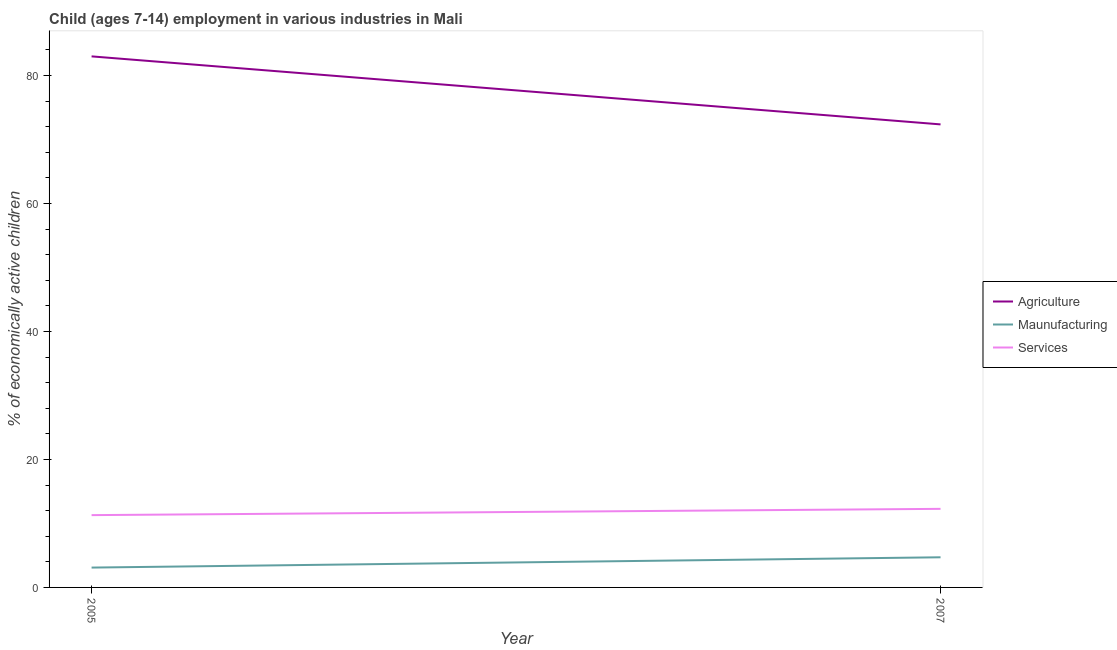What is the percentage of economically active children in manufacturing in 2007?
Your answer should be very brief. 4.71. Across all years, what is the maximum percentage of economically active children in agriculture?
Offer a terse response. 83. Across all years, what is the minimum percentage of economically active children in services?
Ensure brevity in your answer.  11.3. What is the total percentage of economically active children in manufacturing in the graph?
Your response must be concise. 7.81. What is the difference between the percentage of economically active children in manufacturing in 2005 and that in 2007?
Offer a very short reply. -1.61. What is the difference between the percentage of economically active children in services in 2007 and the percentage of economically active children in manufacturing in 2005?
Give a very brief answer. 9.18. What is the average percentage of economically active children in agriculture per year?
Provide a succinct answer. 77.69. In the year 2005, what is the difference between the percentage of economically active children in agriculture and percentage of economically active children in services?
Provide a succinct answer. 71.7. In how many years, is the percentage of economically active children in manufacturing greater than 52 %?
Provide a succinct answer. 0. What is the ratio of the percentage of economically active children in agriculture in 2005 to that in 2007?
Give a very brief answer. 1.15. In how many years, is the percentage of economically active children in services greater than the average percentage of economically active children in services taken over all years?
Provide a short and direct response. 1. Does the percentage of economically active children in services monotonically increase over the years?
Your answer should be very brief. Yes. Is the percentage of economically active children in services strictly greater than the percentage of economically active children in agriculture over the years?
Provide a short and direct response. No. Is the percentage of economically active children in services strictly less than the percentage of economically active children in manufacturing over the years?
Offer a very short reply. No. How many years are there in the graph?
Provide a short and direct response. 2. Does the graph contain any zero values?
Your answer should be very brief. No. How many legend labels are there?
Keep it short and to the point. 3. What is the title of the graph?
Your answer should be very brief. Child (ages 7-14) employment in various industries in Mali. Does "Coal sources" appear as one of the legend labels in the graph?
Your answer should be compact. No. What is the label or title of the X-axis?
Give a very brief answer. Year. What is the label or title of the Y-axis?
Provide a succinct answer. % of economically active children. What is the % of economically active children in Agriculture in 2005?
Your response must be concise. 83. What is the % of economically active children of Agriculture in 2007?
Give a very brief answer. 72.37. What is the % of economically active children in Maunufacturing in 2007?
Provide a short and direct response. 4.71. What is the % of economically active children of Services in 2007?
Make the answer very short. 12.28. Across all years, what is the maximum % of economically active children of Agriculture?
Your answer should be very brief. 83. Across all years, what is the maximum % of economically active children of Maunufacturing?
Your answer should be very brief. 4.71. Across all years, what is the maximum % of economically active children in Services?
Keep it short and to the point. 12.28. Across all years, what is the minimum % of economically active children in Agriculture?
Offer a very short reply. 72.37. Across all years, what is the minimum % of economically active children in Services?
Your answer should be compact. 11.3. What is the total % of economically active children of Agriculture in the graph?
Provide a succinct answer. 155.37. What is the total % of economically active children in Maunufacturing in the graph?
Offer a terse response. 7.81. What is the total % of economically active children in Services in the graph?
Keep it short and to the point. 23.58. What is the difference between the % of economically active children in Agriculture in 2005 and that in 2007?
Your answer should be compact. 10.63. What is the difference between the % of economically active children of Maunufacturing in 2005 and that in 2007?
Ensure brevity in your answer.  -1.61. What is the difference between the % of economically active children in Services in 2005 and that in 2007?
Your response must be concise. -0.98. What is the difference between the % of economically active children of Agriculture in 2005 and the % of economically active children of Maunufacturing in 2007?
Your answer should be very brief. 78.29. What is the difference between the % of economically active children of Agriculture in 2005 and the % of economically active children of Services in 2007?
Offer a terse response. 70.72. What is the difference between the % of economically active children of Maunufacturing in 2005 and the % of economically active children of Services in 2007?
Make the answer very short. -9.18. What is the average % of economically active children of Agriculture per year?
Provide a short and direct response. 77.69. What is the average % of economically active children of Maunufacturing per year?
Your answer should be very brief. 3.9. What is the average % of economically active children in Services per year?
Offer a very short reply. 11.79. In the year 2005, what is the difference between the % of economically active children of Agriculture and % of economically active children of Maunufacturing?
Your answer should be very brief. 79.9. In the year 2005, what is the difference between the % of economically active children of Agriculture and % of economically active children of Services?
Offer a very short reply. 71.7. In the year 2005, what is the difference between the % of economically active children in Maunufacturing and % of economically active children in Services?
Provide a short and direct response. -8.2. In the year 2007, what is the difference between the % of economically active children in Agriculture and % of economically active children in Maunufacturing?
Your answer should be very brief. 67.66. In the year 2007, what is the difference between the % of economically active children of Agriculture and % of economically active children of Services?
Provide a short and direct response. 60.09. In the year 2007, what is the difference between the % of economically active children in Maunufacturing and % of economically active children in Services?
Provide a succinct answer. -7.57. What is the ratio of the % of economically active children of Agriculture in 2005 to that in 2007?
Your answer should be very brief. 1.15. What is the ratio of the % of economically active children in Maunufacturing in 2005 to that in 2007?
Your answer should be compact. 0.66. What is the ratio of the % of economically active children of Services in 2005 to that in 2007?
Offer a terse response. 0.92. What is the difference between the highest and the second highest % of economically active children in Agriculture?
Provide a succinct answer. 10.63. What is the difference between the highest and the second highest % of economically active children in Maunufacturing?
Offer a terse response. 1.61. What is the difference between the highest and the lowest % of economically active children of Agriculture?
Provide a short and direct response. 10.63. What is the difference between the highest and the lowest % of economically active children in Maunufacturing?
Keep it short and to the point. 1.61. 